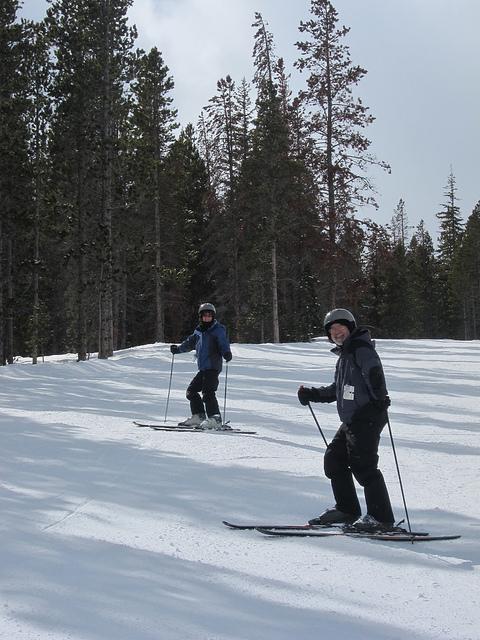Is it sunny?
Keep it brief. Yes. What type of day is it?
Be succinct. Sunny. Is the person on the right smiling?
Quick response, please. Yes. How many skiers are there?
Give a very brief answer. 2. Are they both skating?
Give a very brief answer. No. 